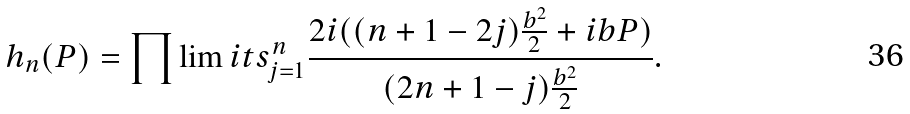Convert formula to latex. <formula><loc_0><loc_0><loc_500><loc_500>h _ { n } ( P ) = \prod \lim i t s _ { j = 1 } ^ { n } \frac { 2 i ( ( n + 1 - 2 j ) \frac { b ^ { 2 } } { 2 } + i b P ) } { ( 2 n + 1 - j ) \frac { b ^ { 2 } } { 2 } } .</formula> 